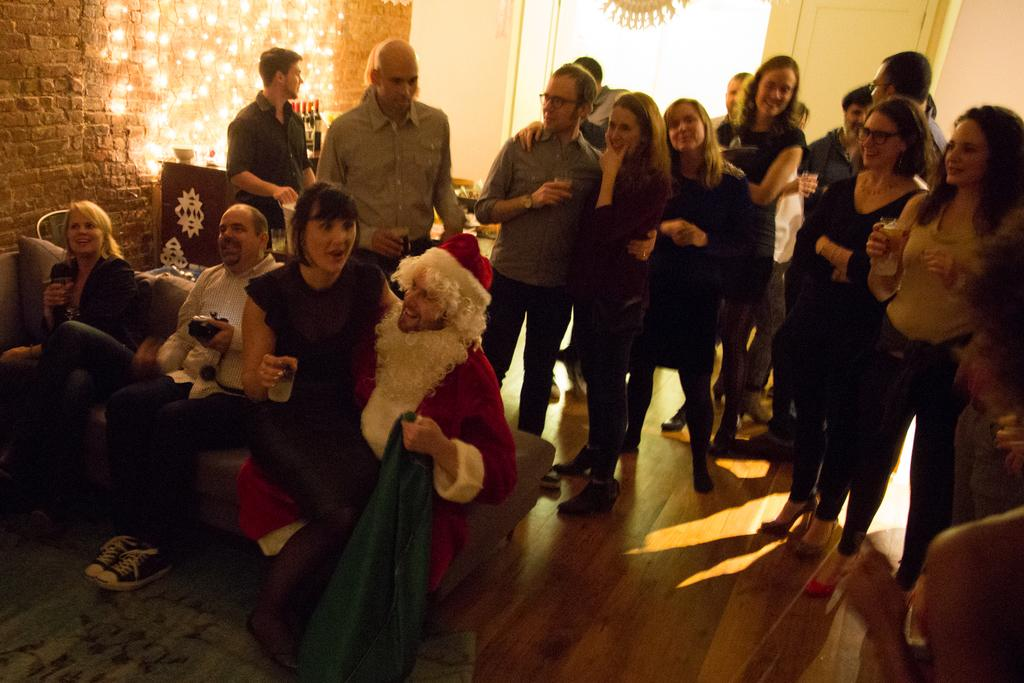What is the main subject of the image? The main subject of the image is a group of people. How are the people in the image arranged? Four people are sitting on a sofa. What type of clover is growing in the alley near the group of people? There is no alley or clover present in the image; it only features a group of people sitting on a sofa. 